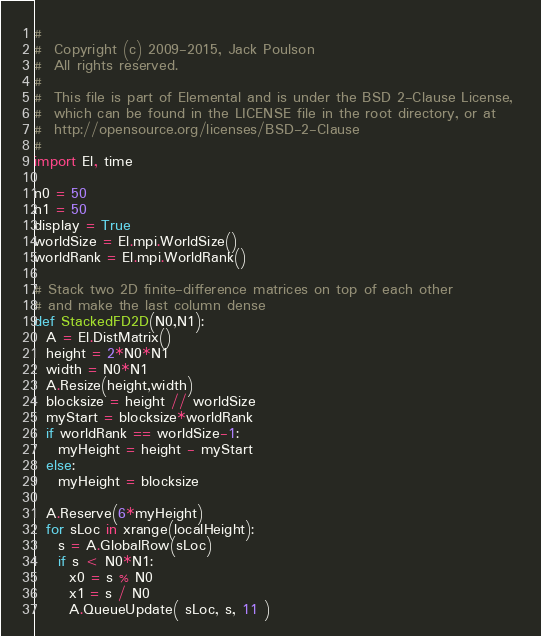<code> <loc_0><loc_0><loc_500><loc_500><_Python_>#
#  Copyright (c) 2009-2015, Jack Poulson
#  All rights reserved.
#
#  This file is part of Elemental and is under the BSD 2-Clause License, 
#  which can be found in the LICENSE file in the root directory, or at 
#  http://opensource.org/licenses/BSD-2-Clause
#
import El, time

n0 = 50
n1 = 50
display = True
worldSize = El.mpi.WorldSize()
worldRank = El.mpi.WorldRank()

# Stack two 2D finite-difference matrices on top of each other
# and make the last column dense
def StackedFD2D(N0,N1):
  A = El.DistMatrix()
  height = 2*N0*N1
  width = N0*N1
  A.Resize(height,width)
  blocksize = height // worldSize
  myStart = blocksize*worldRank
  if worldRank == worldSize-1:
    myHeight = height - myStart
  else:
    myHeight = blocksize
    
  A.Reserve(6*myHeight)
  for sLoc in xrange(localHeight):
    s = A.GlobalRow(sLoc)
    if s < N0*N1:
      x0 = s % N0
      x1 = s / N0
      A.QueueUpdate( sLoc, s, 11 )</code> 